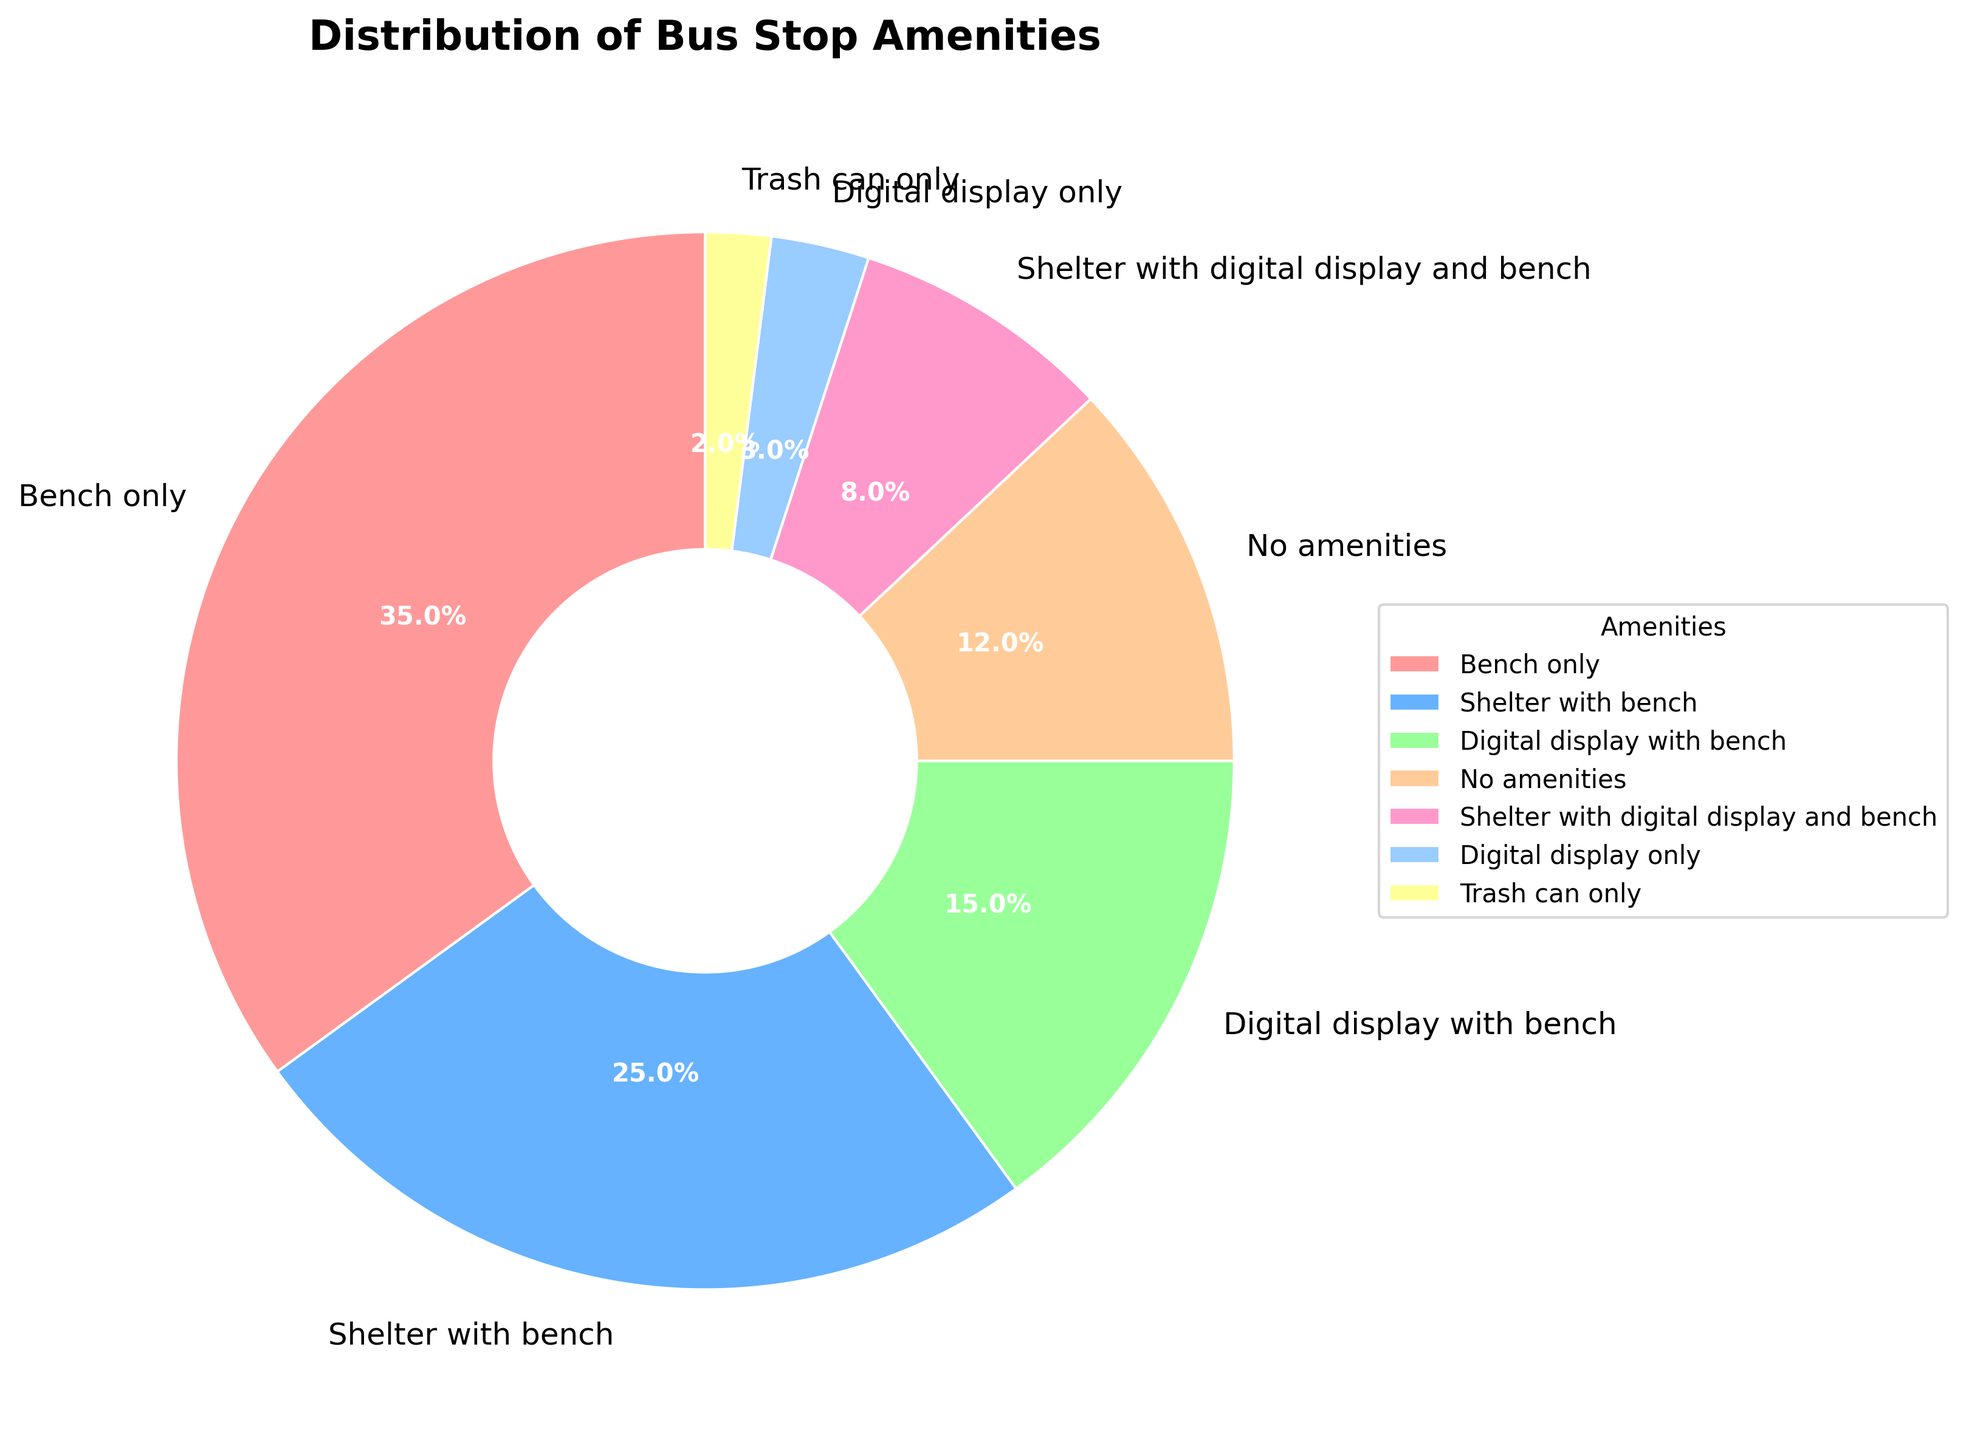What percentage of bus stops have both a shelter and a bench? Referring to the pie chart, the segment labeled "Shelter with bench" indicates the percentage of bus stops with both a shelter and a bench.
Answer: 25% What is the combined percentage of bus stops that have any form of digital display? Sum the percentages of "Digital display with bench" (15%), "Shelter with digital display and bench" (8%), and "Digital display only" (3%). 15% + 8% + 3% = 26%.
Answer: 26% Which amenity category has the lowest percentage? Look for the smallest segment in the pie chart. The segment labeled "Trash can only" has the lowest percentage.
Answer: Trash can only Are there more bus stops with no amenities or those with only a bench? Compare the segments for "No amenities" (12%) and "Bench only" (35%). 35% is greater than 12%.
Answer: Bench only How does the percentage of bus stops with both a bench and a digital display compare to those with no amenities? Compare the segments for "Digital display with bench" (15%) and "No amenities" (12%). 15% is greater than 12%.
Answer: Digital display with bench is greater Are there more bus stops with both a shelter and digital display than those with only a digital display? Compare the segments for "Shelter with digital display and bench" (8%) and "Digital display only" (3%). 8% is greater than 3%.
Answer: Shelter with digital display and bench is greater What is the total percentage of bus stops that have some form of shelter? Sum the percentage of "Shelter with bench" (25%), "Shelter with digital display and bench" (8%). 25% + 8% = 33%.
Answer: 33% Which color segment represents bus stops with only a digital display? Identify the segment labeled "Digital display only" and note its color. It is usually a lighter color in the pie chart.
Answer: Light color (specific color varies) Which two amenities together make up less than 20% of the total? Look for two segments whose percentages add up to less than 20%. "Digital display only" (3%) and "Trash can only" (2%) together sum up to 5%.
Answer: Digital display only and Trash can only 